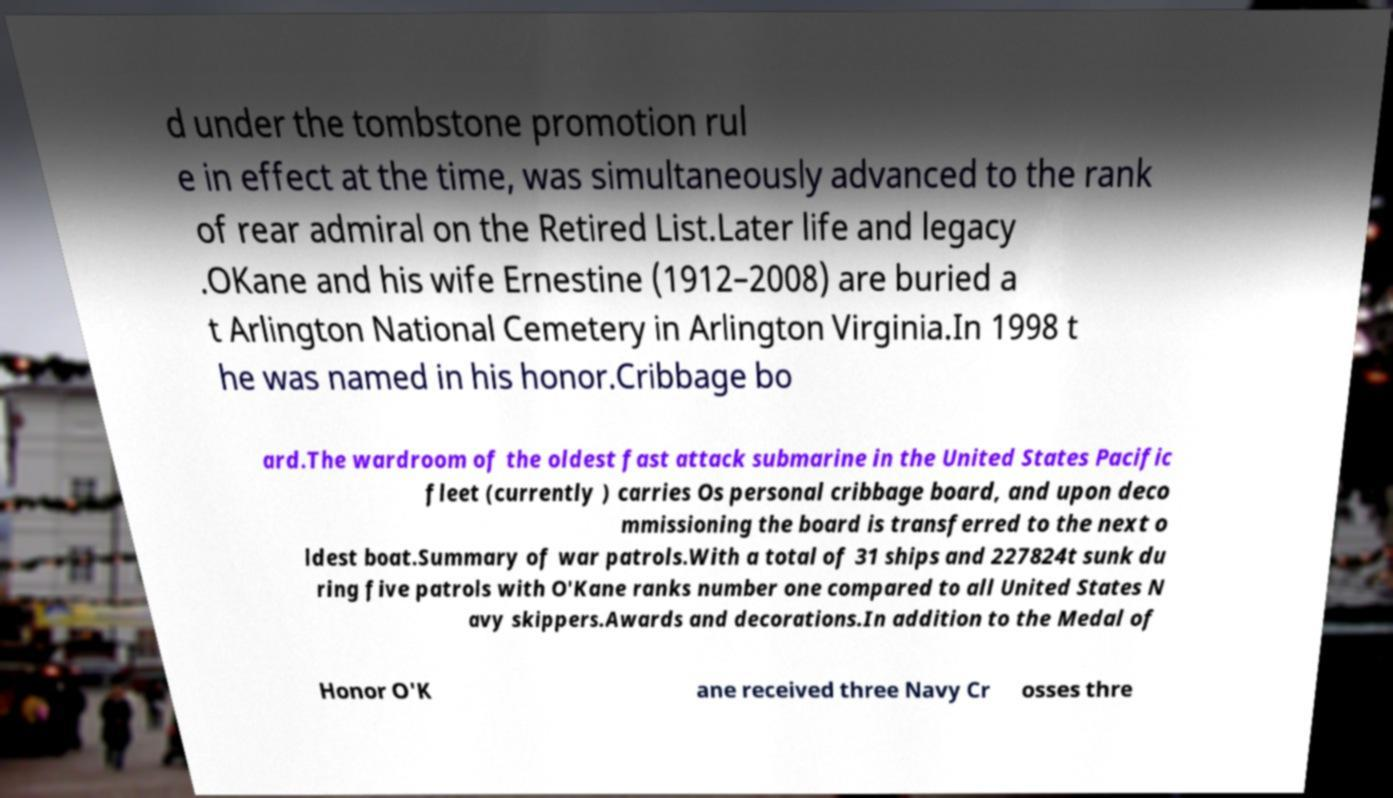Please read and relay the text visible in this image. What does it say? d under the tombstone promotion rul e in effect at the time, was simultaneously advanced to the rank of rear admiral on the Retired List.Later life and legacy .OKane and his wife Ernestine (1912–2008) are buried a t Arlington National Cemetery in Arlington Virginia.In 1998 t he was named in his honor.Cribbage bo ard.The wardroom of the oldest fast attack submarine in the United States Pacific fleet (currently ) carries Os personal cribbage board, and upon deco mmissioning the board is transferred to the next o ldest boat.Summary of war patrols.With a total of 31 ships and 227824t sunk du ring five patrols with O'Kane ranks number one compared to all United States N avy skippers.Awards and decorations.In addition to the Medal of Honor O'K ane received three Navy Cr osses thre 